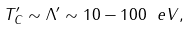Convert formula to latex. <formula><loc_0><loc_0><loc_500><loc_500>T ^ { \prime } _ { C } \sim \Lambda ^ { \prime } \sim 1 0 - 1 0 0 \ e V ,</formula> 